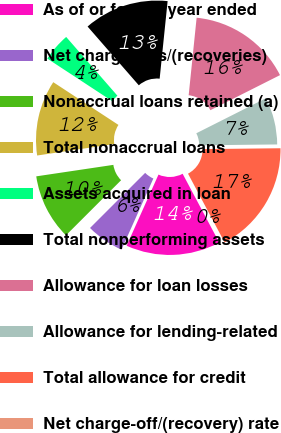Convert chart. <chart><loc_0><loc_0><loc_500><loc_500><pie_chart><fcel>As of or for the year ended<fcel>Net charge-offs/(recoveries)<fcel>Nonaccrual loans retained (a)<fcel>Total nonaccrual loans<fcel>Assets acquired in loan<fcel>Total nonperforming assets<fcel>Allowance for loan losses<fcel>Allowance for lending-related<fcel>Total allowance for credit<fcel>Net charge-off/(recovery) rate<nl><fcel>14.49%<fcel>5.8%<fcel>10.14%<fcel>11.59%<fcel>4.35%<fcel>13.04%<fcel>15.94%<fcel>7.25%<fcel>17.39%<fcel>0.0%<nl></chart> 